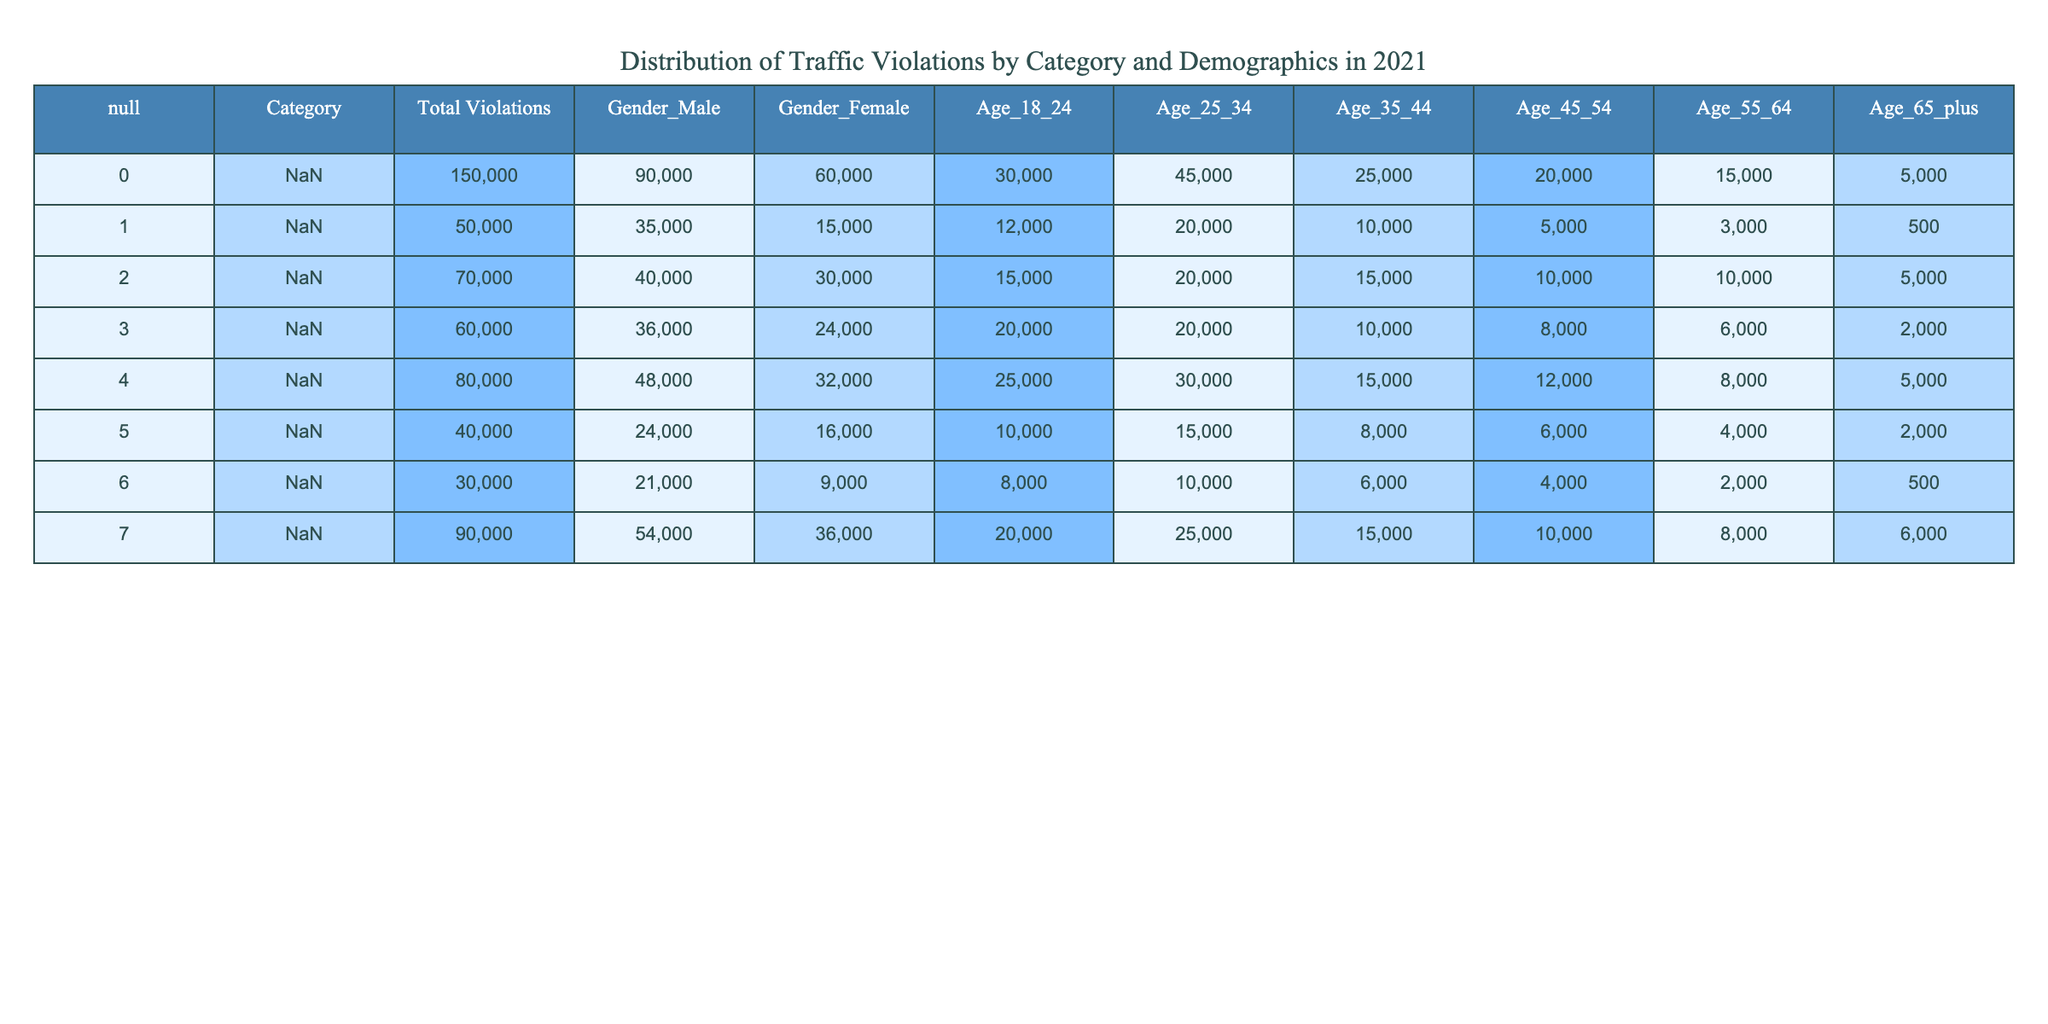What is the total number of traffic violations recorded in 2021? By referring to the "Total Violations" column, we can sum the total violations across all categories. The total is calculated as 150000 + 50000 + 70000 + 60000 + 80000 + 40000 + 30000 + 90000 = 500000.
Answer: 500000 Which category had the highest number of violations? Looking at the "Total Violations" column, the highest value is 150000, which corresponds to the category "Speeding."
Answer: Speeding What percentage of DUI violations were committed by males? To find the percentage of male DUI violations, divide the number of male DUI violations (35000) by the total DUI violations (50000) and multiply by 100: (35000 / 50000) * 100 = 70%.
Answer: 70% How many more speeding violations were there compared to traffic signal violations? First, find the number of speeding violations (150000) and the number of traffic signal violations (40000). The difference is calculated as 150000 - 40000 = 110000.
Answer: 110000 Is the number of seat belt violations greater than the number of reckless driving violations? By looking at the "Total Violations" column, seat belt violations are 70000 and reckless driving violations are 30000. Since 70000 is greater than 30000, the statement is true.
Answer: Yes What is the average number of violations for the age group 25-34 across all categories? The violations for this age group from each category are: 45000 (Speeding), 20000 (DUI), 20000 (Seat Belt Violation), 20000 (Running a Red Light), 30000 (Distracted Driving), 15000 (Traffic Signal Violation), 10000 (Reckless Driving), and 25000 (Parking Violation). The sum is 45000 + 20000 + 20000 + 20000 + 30000 + 15000 + 10000 + 25000 = 185000. To find the average, divide by the number of categories (8): 185000 / 8 = 23125.
Answer: 23125 What are the total violations for females aged 65 and older? Displaying the data for females aged 65 and older from the "Age_65_plus" column: 5000 (Speeding), 500 (DUI), 5000 (Seat Belt Violation), 2000 (Running a Red Light), 5000 (Distracted Driving), 2000 (Traffic Signal Violation), 500 (Reckless Driving), and 6000 (Parking Violation). Summing those values results in 5000 + 500 + 5000 + 2000 + 5000 + 2000 + 500 + 6000 = 20000.
Answer: 20000 Which category had more total violations: distracted driving or running a red light? Checking the "Total Violations" for distracted driving, which is 80000, and for running a red light, which is 60000. Therefore, distracted driving has more violations than running a red light.
Answer: Distracted driving How many violations for males aged 18-24 are there in total? The violations for males in the age group 18-24, found in the respective categories, are: 30000 (Speeding), 12000 (DUI), 15000 (Seat Belt Violation), 20000 (Running a Red Light), 25000 (Distracted Driving), 10000 (Traffic Signal Violation), 8000 (Reckless Driving), and 20000 (Parking Violation). Summing these gives us: 30000 + 12000 + 15000 + 20000 + 25000 + 10000 + 8000 + 20000 = 130000.
Answer: 130000 